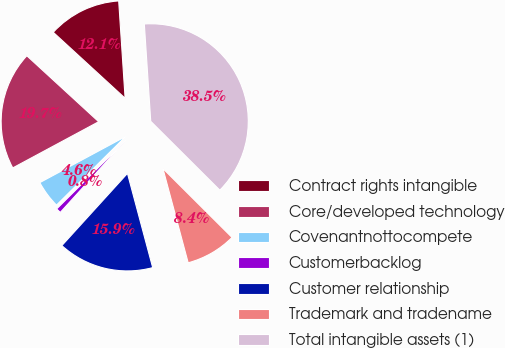Convert chart to OTSL. <chart><loc_0><loc_0><loc_500><loc_500><pie_chart><fcel>Contract rights intangible<fcel>Core/developed technology<fcel>Covenantnottocompete<fcel>Customerbacklog<fcel>Customer relationship<fcel>Trademark and tradename<fcel>Total intangible assets (1)<nl><fcel>12.13%<fcel>19.67%<fcel>4.59%<fcel>0.82%<fcel>15.9%<fcel>8.36%<fcel>38.52%<nl></chart> 